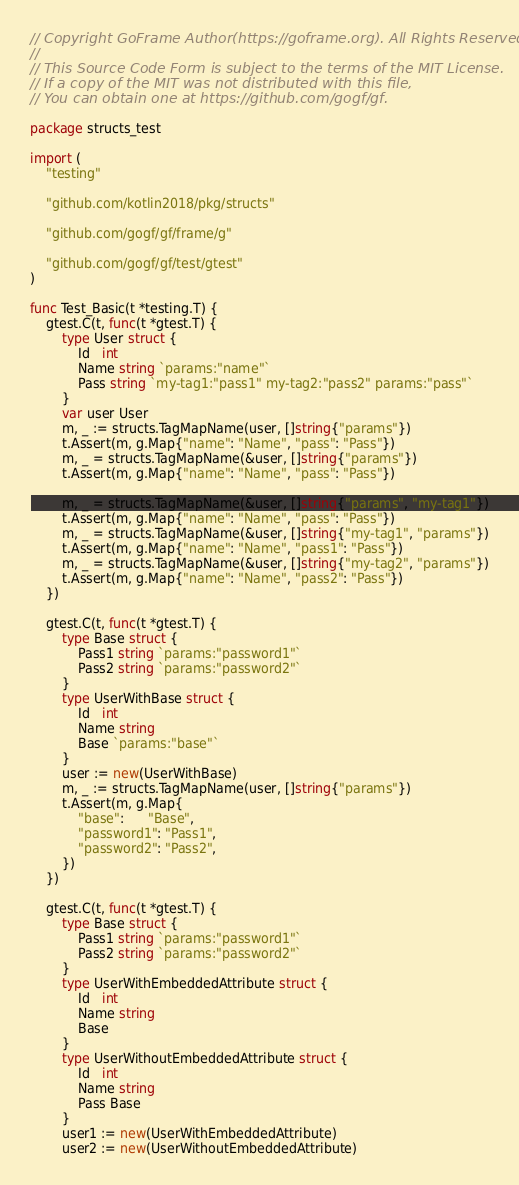Convert code to text. <code><loc_0><loc_0><loc_500><loc_500><_Go_>// Copyright GoFrame Author(https://goframe.org). All Rights Reserved.
//
// This Source Code Form is subject to the terms of the MIT License.
// If a copy of the MIT was not distributed with this file,
// You can obtain one at https://github.com/gogf/gf.

package structs_test

import (
	"testing"

	"github.com/kotlin2018/pkg/structs"

	"github.com/gogf/gf/frame/g"

	"github.com/gogf/gf/test/gtest"
)

func Test_Basic(t *testing.T) {
	gtest.C(t, func(t *gtest.T) {
		type User struct {
			Id   int
			Name string `params:"name"`
			Pass string `my-tag1:"pass1" my-tag2:"pass2" params:"pass"`
		}
		var user User
		m, _ := structs.TagMapName(user, []string{"params"})
		t.Assert(m, g.Map{"name": "Name", "pass": "Pass"})
		m, _ = structs.TagMapName(&user, []string{"params"})
		t.Assert(m, g.Map{"name": "Name", "pass": "Pass"})

		m, _ = structs.TagMapName(&user, []string{"params", "my-tag1"})
		t.Assert(m, g.Map{"name": "Name", "pass": "Pass"})
		m, _ = structs.TagMapName(&user, []string{"my-tag1", "params"})
		t.Assert(m, g.Map{"name": "Name", "pass1": "Pass"})
		m, _ = structs.TagMapName(&user, []string{"my-tag2", "params"})
		t.Assert(m, g.Map{"name": "Name", "pass2": "Pass"})
	})

	gtest.C(t, func(t *gtest.T) {
		type Base struct {
			Pass1 string `params:"password1"`
			Pass2 string `params:"password2"`
		}
		type UserWithBase struct {
			Id   int
			Name string
			Base `params:"base"`
		}
		user := new(UserWithBase)
		m, _ := structs.TagMapName(user, []string{"params"})
		t.Assert(m, g.Map{
			"base":      "Base",
			"password1": "Pass1",
			"password2": "Pass2",
		})
	})

	gtest.C(t, func(t *gtest.T) {
		type Base struct {
			Pass1 string `params:"password1"`
			Pass2 string `params:"password2"`
		}
		type UserWithEmbeddedAttribute struct {
			Id   int
			Name string
			Base
		}
		type UserWithoutEmbeddedAttribute struct {
			Id   int
			Name string
			Pass Base
		}
		user1 := new(UserWithEmbeddedAttribute)
		user2 := new(UserWithoutEmbeddedAttribute)</code> 